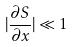Convert formula to latex. <formula><loc_0><loc_0><loc_500><loc_500>| \frac { \partial S } { \partial x } | \ll 1</formula> 